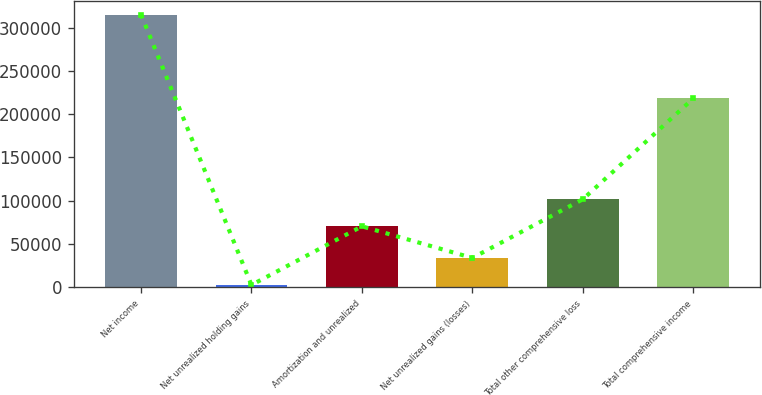<chart> <loc_0><loc_0><loc_500><loc_500><bar_chart><fcel>Net income<fcel>Net unrealized holding gains<fcel>Amortization and unrealized<fcel>Net unrealized gains (losses)<fcel>Total other comprehensive loss<fcel>Total comprehensive income<nl><fcel>315075<fcel>2713<fcel>70461<fcel>33949.2<fcel>101697<fcel>218138<nl></chart> 